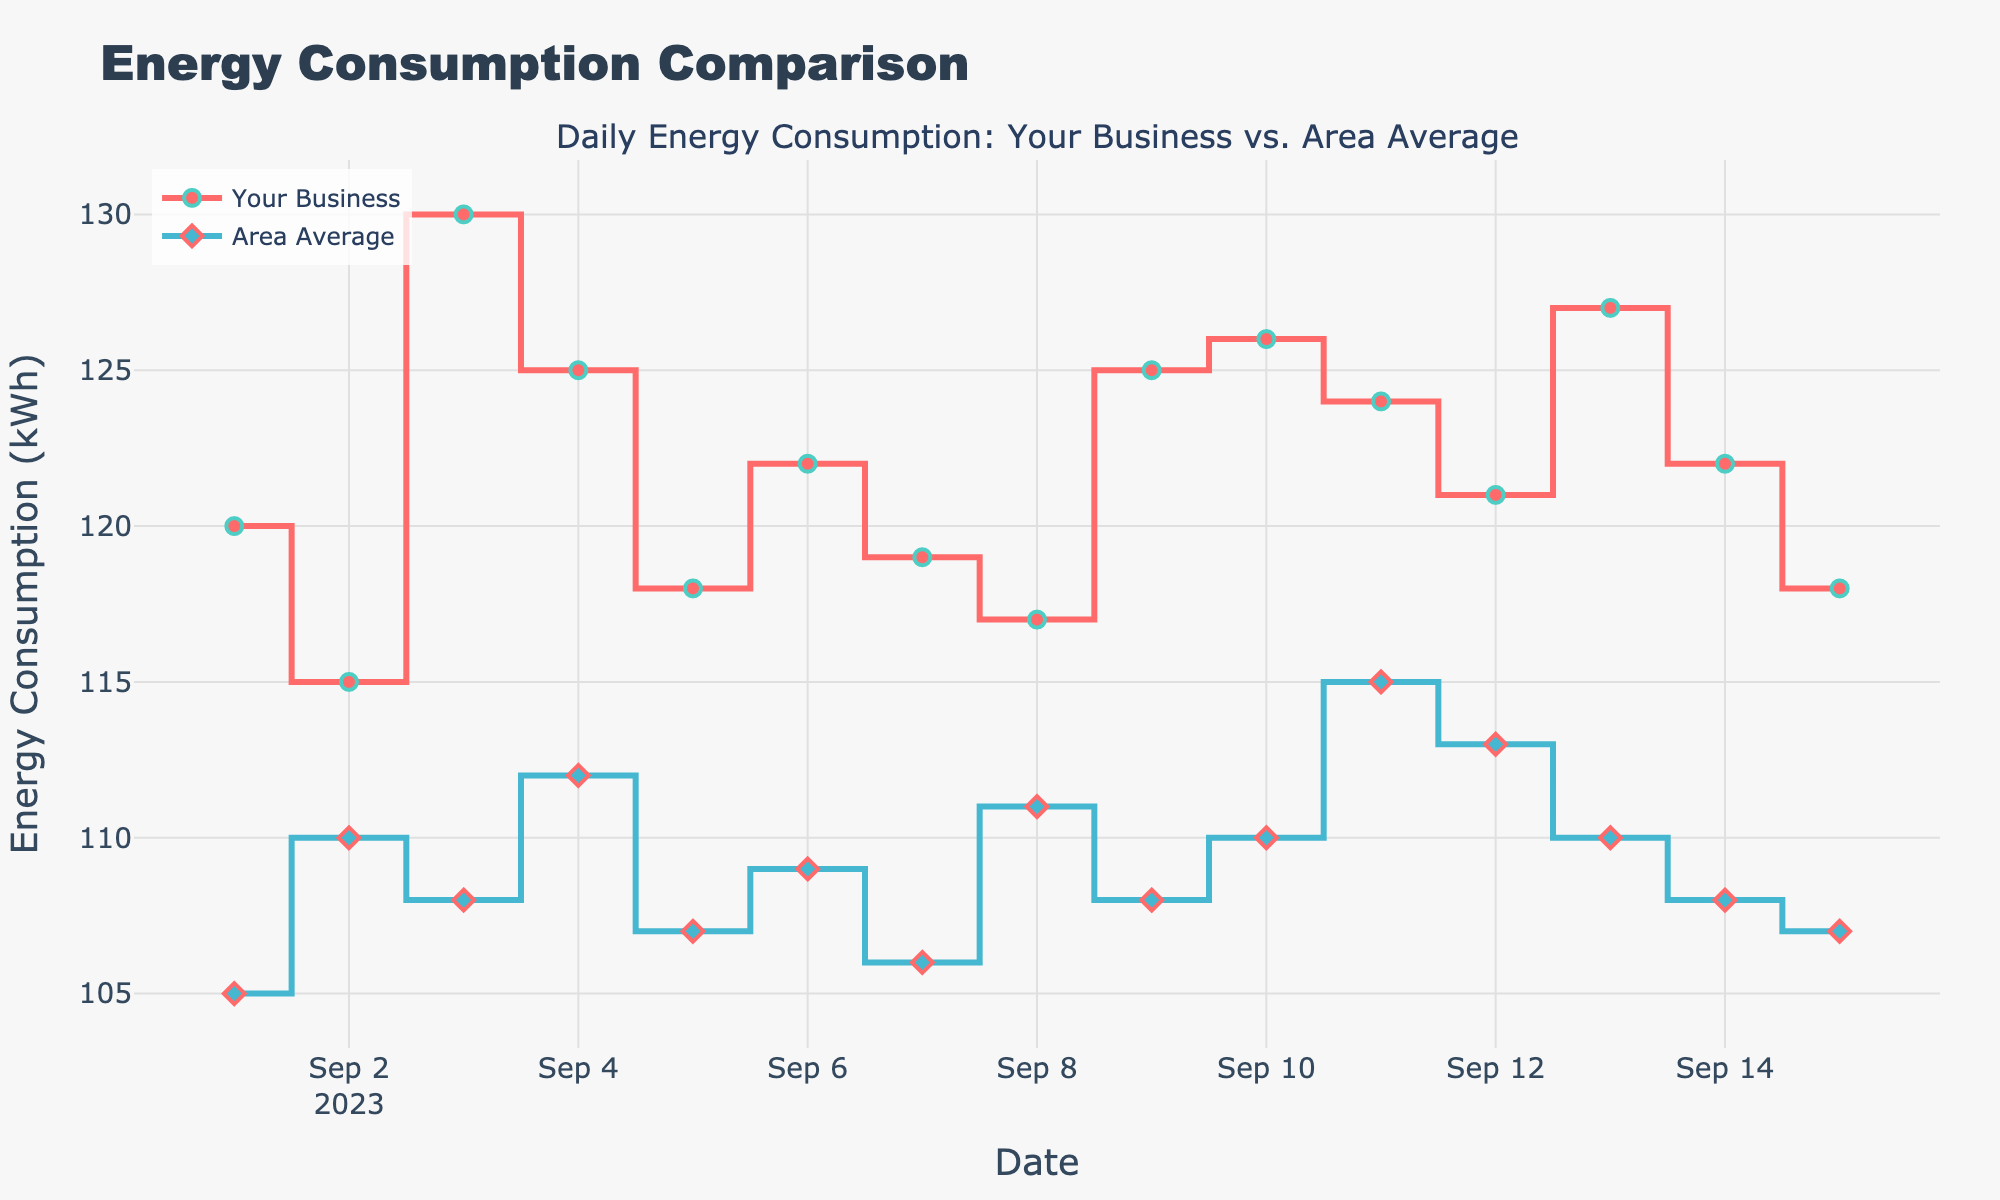Which date has the highest energy consumption for your business? Look at the vertical axis and find the date with the highest value on the red stair plot labeled "Your Business". The highest value is on 2023-09-03 with 130 kWh.
Answer: 2023-09-03 Is there any date where the average consumption in the area exceeded your business's consumption? Compare the stair plots for your business and the area. Look for dates where the blue stair plot is above the red stair plot. This occurs on 2023-09-11 where the area's consumption was 115 kWh and your business was 124 kWh.
Answer: No What is the total energy consumption for your business from September 1 to September 5? Sum up the values of the red stair plot from September 1 to September 5. Add 120 + 115 + 130 + 125 + 118 to get the total consumption.
Answer: 608 kWh Which date shows the smallest difference in energy consumption between your business and the area average? Calculate the difference for each date by subtracting the area average from your business's consumption and find the smallest difference. On 2023-09-08, both your business and the area had the same consumption, 117 kWh.
Answer: 2023-09-08 On which date does your business have a consumption of 118 kWh? Find the point on the red stair plot corresponding to 118 kWh. This occurs on September 5 and September 15.
Answer: 2023-09-05 and 2023-09-15 What is the average daily consumption for your business over the period shown? Sum the daily consumption values for your business and divide by the number of dates. Sum up the values (120 + 115 + 130 + 125 + 118 + 122 + 119 + 117 + 125 + 126 + 124 + 121 + 127 + 122 + 118) which gives 1809 kWh, then divide by 15.
Answer: 120.6 kWh How does the energy consumption trend for your business compare to the area average over the period? Observe the overall direction and movement of both the red and blue plots. Both tend to increase and decrease in a similar pattern with your business consistently higher than the area average.
Answer: Consistently higher than area average What is the difference in energy consumption between the highest and lowest days for your business? Find the highest consumption day (130 kWh on September 3) and the lowest (115 kWh on September 2), then subtract the lowest from the highest.
Answer: 15 kWh Which date had the highest average daily consumption in the area? Look at the vertical axis and find the highest value on the blue stair plot labeled "Area Average". The highest value is on 2023-09-11 with 115 kWh.
Answer: 2023-09-11 